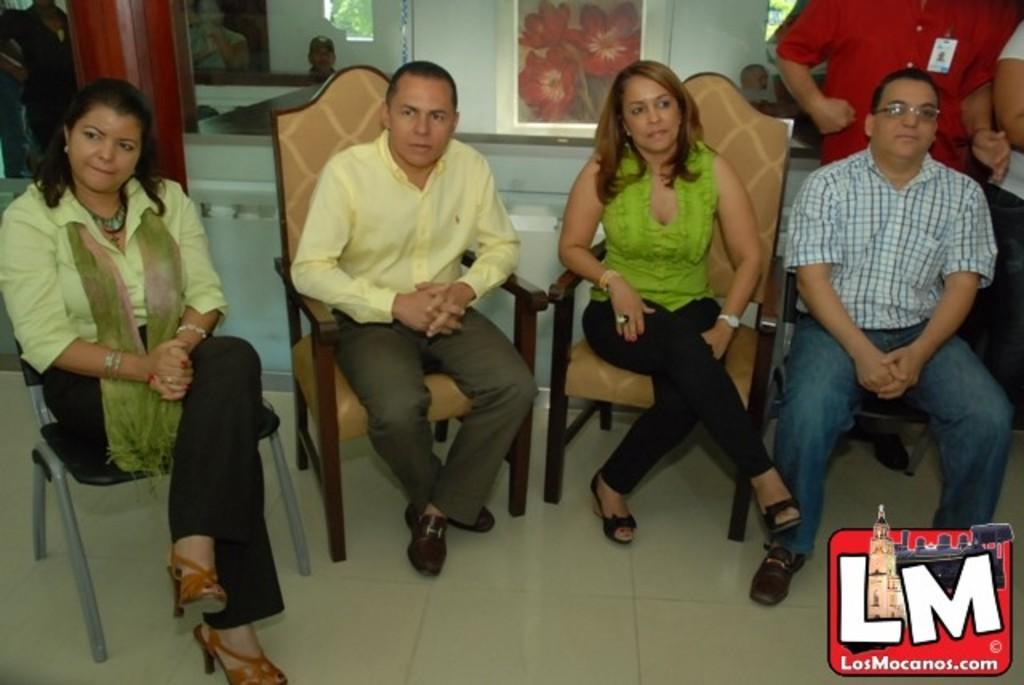In one or two sentences, can you explain what this image depicts? On the left side a woman is sitting on the chair, she wore shirt, trouser. In the middle a man is there. He wore yellow color shirt, beside him there is a beautiful woman, she wore a green color top and black color trouser. On the right side a man is sitting, he wore shirt, trouser, spectacles 